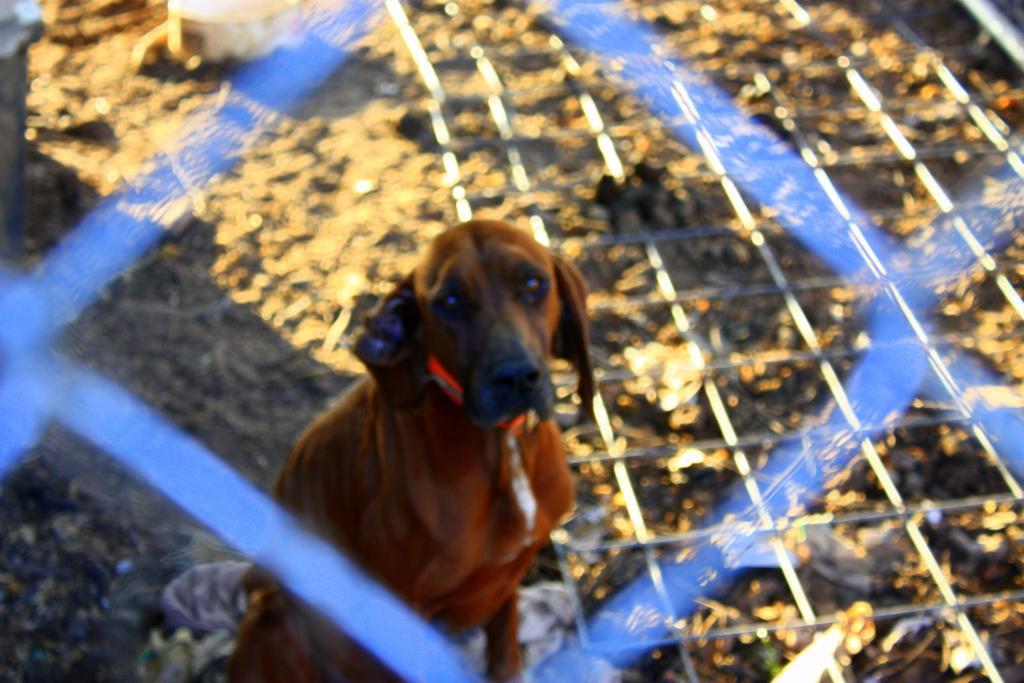What is the main subject in the center of the image? There is a dog in the center of the image. What can be seen in the background of the image? There is a fence in the image. What object is on the ground in the image? There is a container on the ground in the image. What type of magic is being performed by the dog in the image? There is no magic or any indication of magic being performed in the image; it simply shows a dog and other elements. 